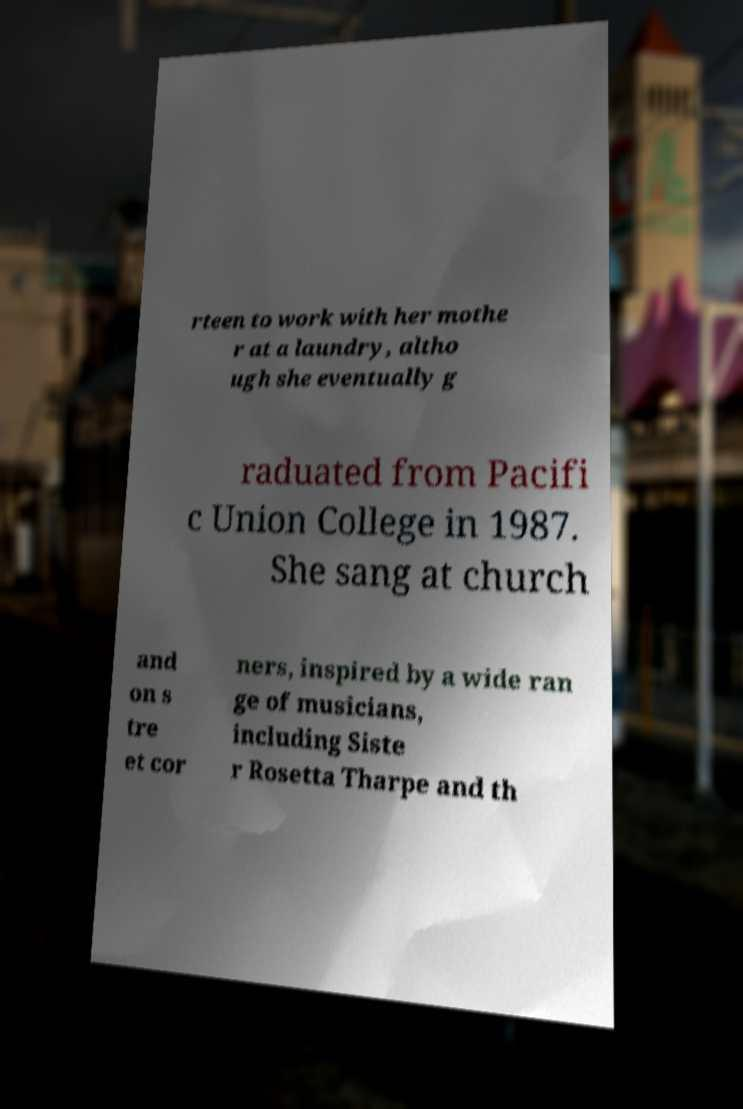Please read and relay the text visible in this image. What does it say? rteen to work with her mothe r at a laundry, altho ugh she eventually g raduated from Pacifi c Union College in 1987. She sang at church and on s tre et cor ners, inspired by a wide ran ge of musicians, including Siste r Rosetta Tharpe and th 